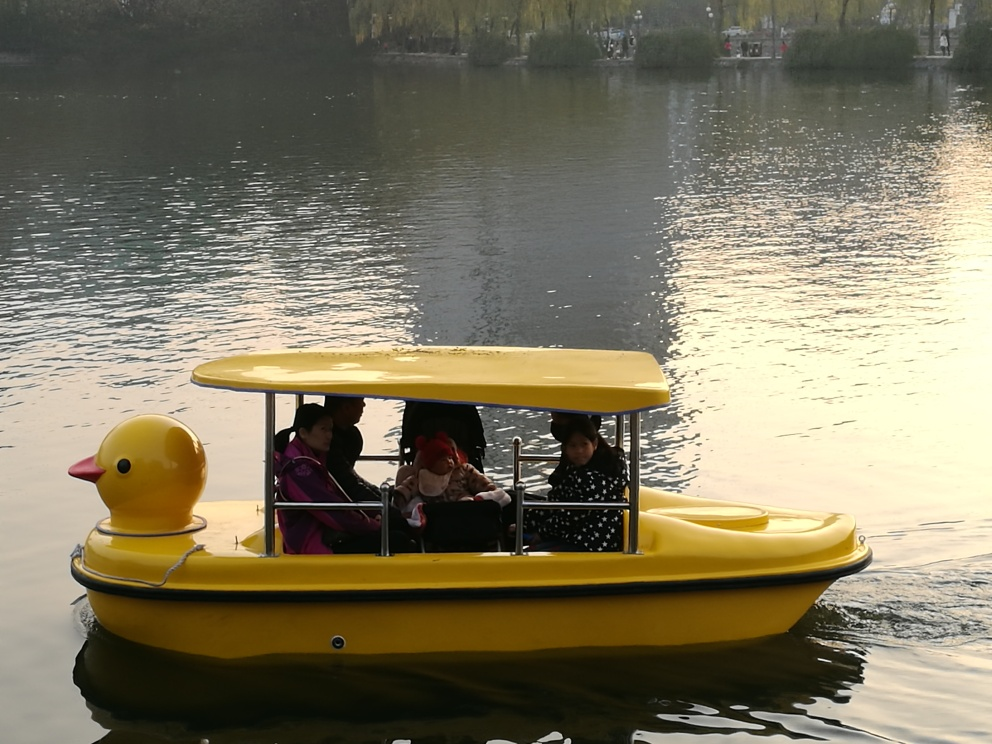Can you tell me what activity the people are engaged in? The individuals in the image are on a leisurely boat ride in a vessel designed to resemble a duck, which is likely a recreational activity offered at the location. 